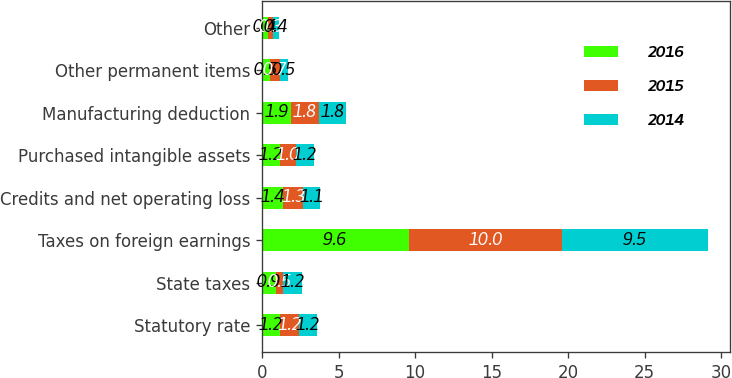Convert chart. <chart><loc_0><loc_0><loc_500><loc_500><stacked_bar_chart><ecel><fcel>Statutory rate<fcel>State taxes<fcel>Taxes on foreign earnings<fcel>Credits and net operating loss<fcel>Purchased intangible assets<fcel>Manufacturing deduction<fcel>Other permanent items<fcel>Other<nl><fcel>2016<fcel>1.2<fcel>0.9<fcel>9.6<fcel>1.4<fcel>1.2<fcel>1.9<fcel>0.5<fcel>0.4<nl><fcel>2015<fcel>1.2<fcel>0.5<fcel>10<fcel>1.3<fcel>1<fcel>1.8<fcel>0.7<fcel>0.3<nl><fcel>2014<fcel>1.2<fcel>1.2<fcel>9.5<fcel>1.1<fcel>1.2<fcel>1.8<fcel>0.5<fcel>0.4<nl></chart> 